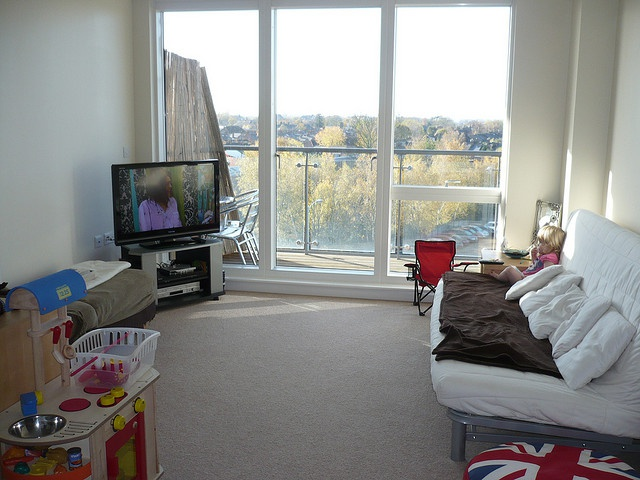Describe the objects in this image and their specific colors. I can see couch in gray, darkgray, black, and lightgray tones, oven in gray, black, maroon, and olive tones, couch in gray, black, and maroon tones, tv in gray, black, teal, and purple tones, and bed in gray, black, and darkgray tones in this image. 